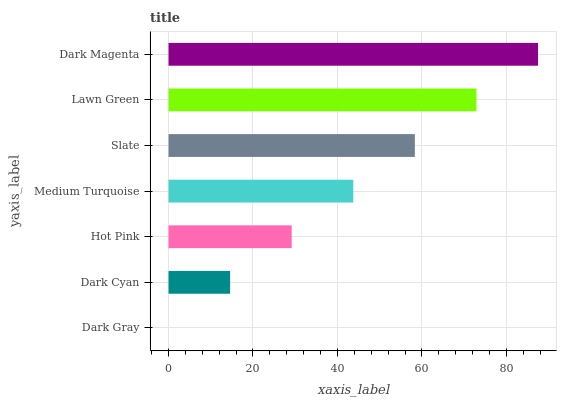Is Dark Gray the minimum?
Answer yes or no. Yes. Is Dark Magenta the maximum?
Answer yes or no. Yes. Is Dark Cyan the minimum?
Answer yes or no. No. Is Dark Cyan the maximum?
Answer yes or no. No. Is Dark Cyan greater than Dark Gray?
Answer yes or no. Yes. Is Dark Gray less than Dark Cyan?
Answer yes or no. Yes. Is Dark Gray greater than Dark Cyan?
Answer yes or no. No. Is Dark Cyan less than Dark Gray?
Answer yes or no. No. Is Medium Turquoise the high median?
Answer yes or no. Yes. Is Medium Turquoise the low median?
Answer yes or no. Yes. Is Hot Pink the high median?
Answer yes or no. No. Is Lawn Green the low median?
Answer yes or no. No. 